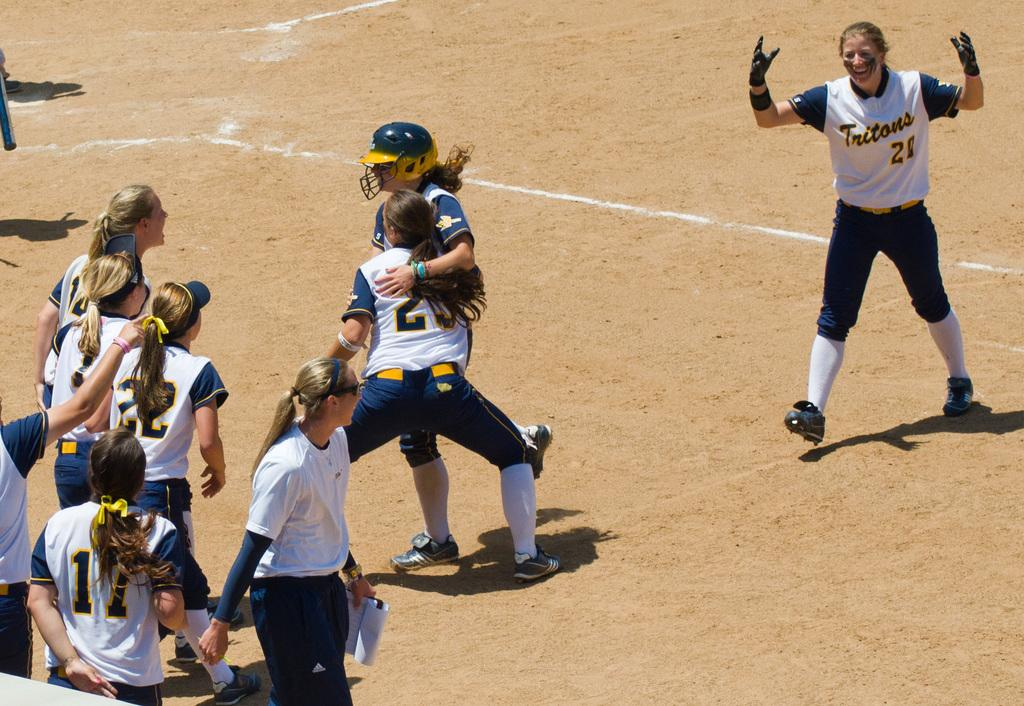<image>
Present a compact description of the photo's key features. players including number 17 and 22 are walking toward the catcher 